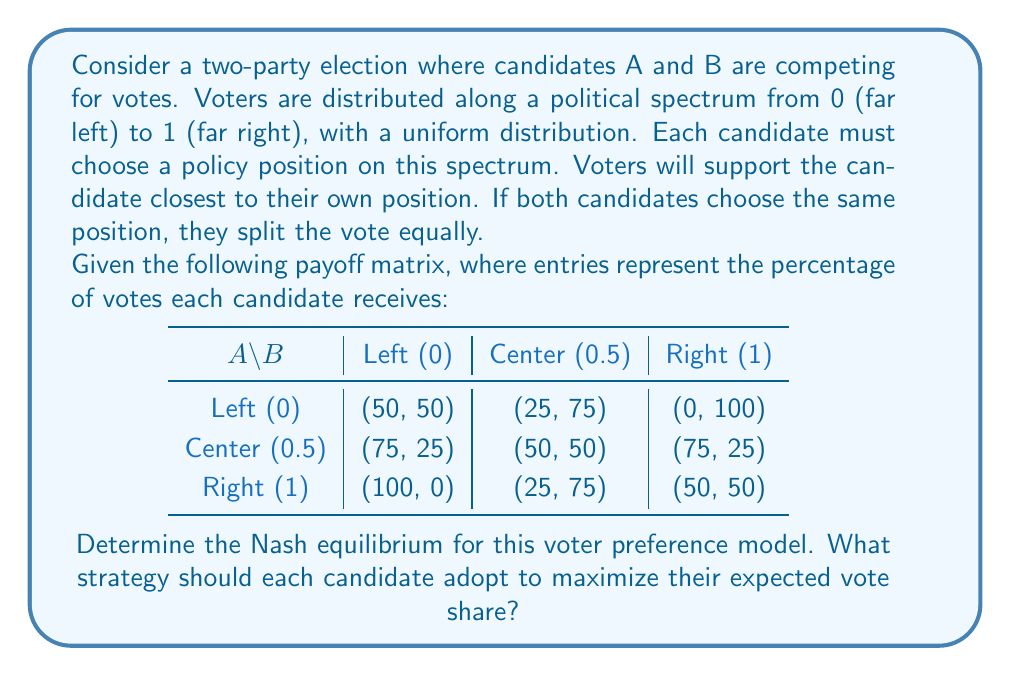Solve this math problem. To find the Nash equilibrium, we need to analyze each candidate's best response to the other's strategy:

1. If B chooses Left (0):
   A's best response is Center (0.5), giving 75% of the vote.

2. If B chooses Center (0.5):
   A's best response is either Left (0) or Right (1), each giving 25% of the vote.

3. If B chooses Right (1):
   A's best response is Center (0.5), giving 75% of the vote.

4. If A chooses Left (0):
   B's best response is Center (0.5), giving 75% of the vote.

5. If A chooses Center (0.5):
   B's best response is either Left (0) or Right (1), each giving 25% of the vote.

6. If A chooses Right (1):
   B's best response is Center (0.5), giving 75% of the vote.

The Nash equilibrium occurs when neither player can unilaterally improve their payoff by changing their strategy. In this case, we can see that when both candidates choose Center (0.5), neither has an incentive to deviate:

- If A moves to Left or Right, their vote share decreases from 50% to 25%.
- If B moves to Left or Right, their vote share also decreases from 50% to 25%.

Therefore, the Nash equilibrium is for both candidates to choose the Center (0.5) position.

This result aligns with the Median Voter Theorem, which states that in a two-party system with a single-peaked preference distribution, both parties will converge to the median voter's preferred position to maximize their vote share.
Answer: The Nash equilibrium for this voter preference model is (Center, Center), where both candidates A and B choose the Center (0.5) position on the political spectrum. 